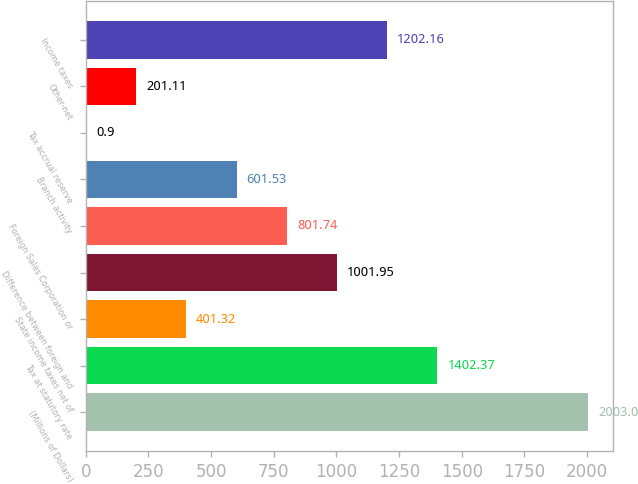Convert chart. <chart><loc_0><loc_0><loc_500><loc_500><bar_chart><fcel>(Millions of Dollars)<fcel>Tax at statutory rate<fcel>State income taxes net of<fcel>Difference between foreign and<fcel>Foreign Sales Corporation or<fcel>Branch activity<fcel>Tax accrual reserve<fcel>Other-net<fcel>Income taxes<nl><fcel>2003<fcel>1402.37<fcel>401.32<fcel>1001.95<fcel>801.74<fcel>601.53<fcel>0.9<fcel>201.11<fcel>1202.16<nl></chart> 